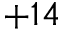Convert formula to latex. <formula><loc_0><loc_0><loc_500><loc_500>+ 1 4</formula> 